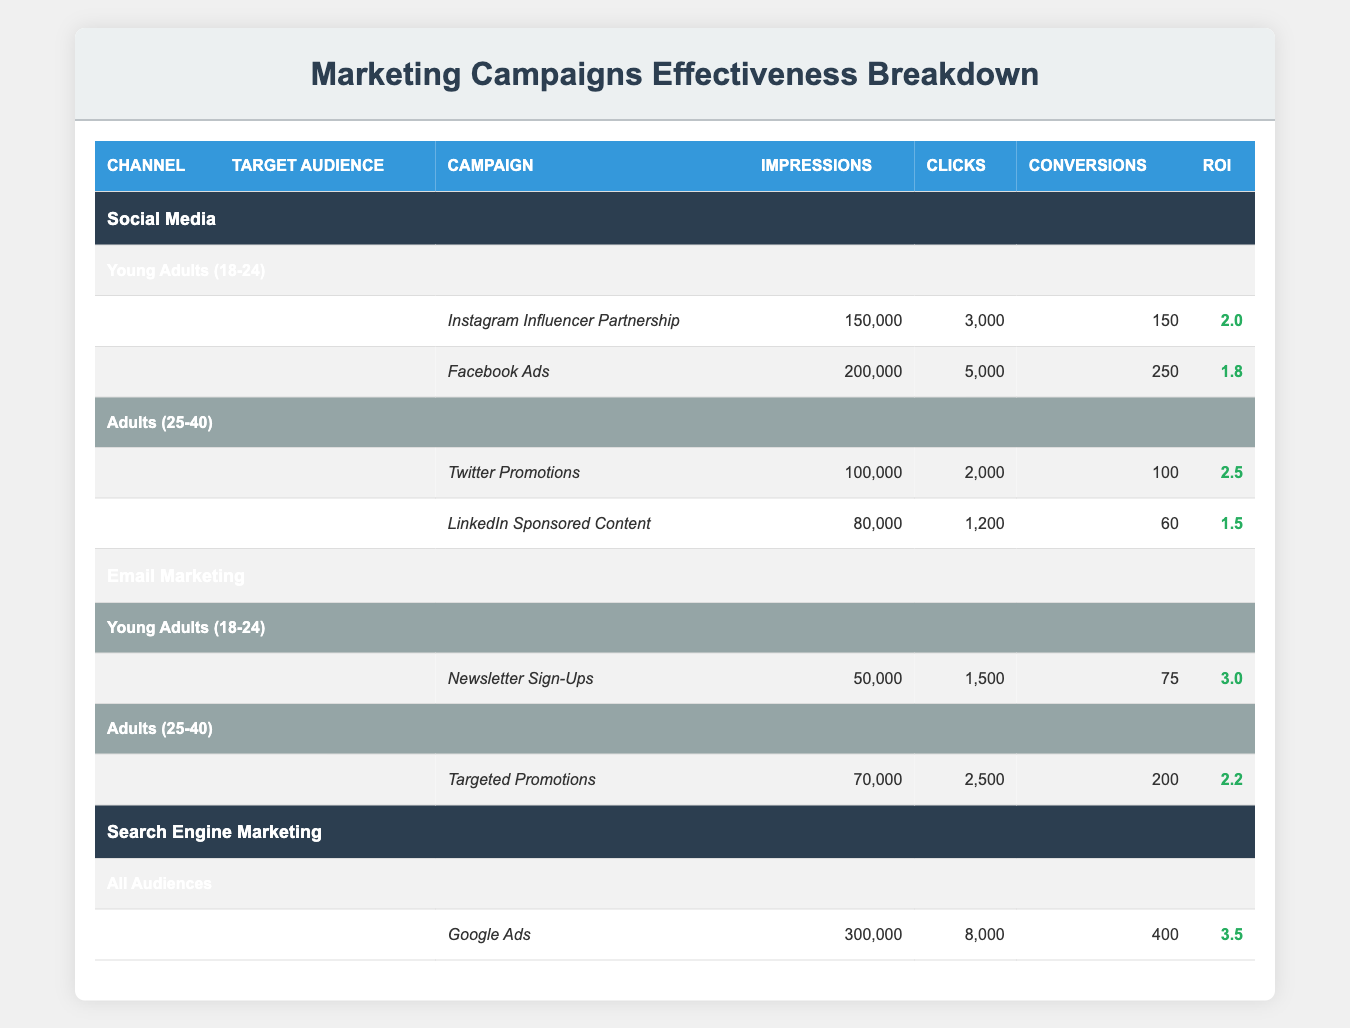What is the ROI for the "Newsletter Sign-Ups" campaign? The ROI for the "Newsletter Sign-Ups" campaign can be found in the Email Marketing section under the Young Adults (18-24) audience. It states that the ROI is 3.0.
Answer: 3.0 Which channel had the highest number of impressions? The total number of impressions for each channel must be compared. Social Media had 150,000 + 200,000 + 100,000 + 80,000 = 530,000 impressions. Email Marketing had 50,000 + 70,000 = 120,000 impressions, and Search Engine Marketing had 300,000 impressions. Thus, Social Media has the highest number of impressions.
Answer: Social Media How many conversions were generated by the "Google Ads" campaign? The “Google Ads” campaign is found in the Search Engine Marketing section under All Audiences. It states that there were 400 conversions generated by this campaign.
Answer: 400 What is the total number of conversions generated by Social Media campaigns? To find the total conversions from Social Media, we sum the conversions from both campaigns for Young Adults and Adults: 150 (Instagram Influencer Partnership) + 250 (Facebook Ads) + 100 (Twitter Promotions) + 60 (LinkedIn Sponsored Content) = 560.
Answer: 560 Is the ROI for the "Twitter Promotions" campaign higher than for "LinkedIn Sponsored Content"? The ROI for "Twitter Promotions" is 2.5, while for "LinkedIn Sponsored Content," it is 1.5. Since 2.5 is greater than 1.5, the answer is yes.
Answer: Yes What is the average ROI for Email Marketing campaigns targeting Adults (25-40)? The ROI for Email Marketing targeting Adults (25-40) is 2.2 (from Targeted Promotions). Since there is only one campaign in this segment, the average ROI is the same as the ROI of that campaign, which is 2.2.
Answer: 2.2 How many more clicks did Google Ads get compared to the total clicks from Email Marketing campaigns? Google Ads received 8,000 clicks. Email Marketing campaigns under Young Adults (18-24) received 1,500 (Newsletter Sign-Ups) and under Adults (25-40) received 2,500 (Targeted Promotions), totaling 4,000 clicks. Thus, 8,000 - 4,000 = 4,000 more clicks from Google Ads compared to Email Marketing.
Answer: 4,000 What percentage of impressions resulted in conversions for the "Facebook Ads" campaign? The "Facebook Ads" campaign had 200,000 impressions and 250 conversions. The percentage is calculated as (250 / 200,000) * 100 = 0.125%.
Answer: 0.125% 